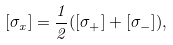Convert formula to latex. <formula><loc_0><loc_0><loc_500><loc_500>[ \sigma _ { x } ] = \frac { 1 } { 2 } ( [ \sigma _ { + } ] + [ \sigma _ { - } ] ) ,</formula> 